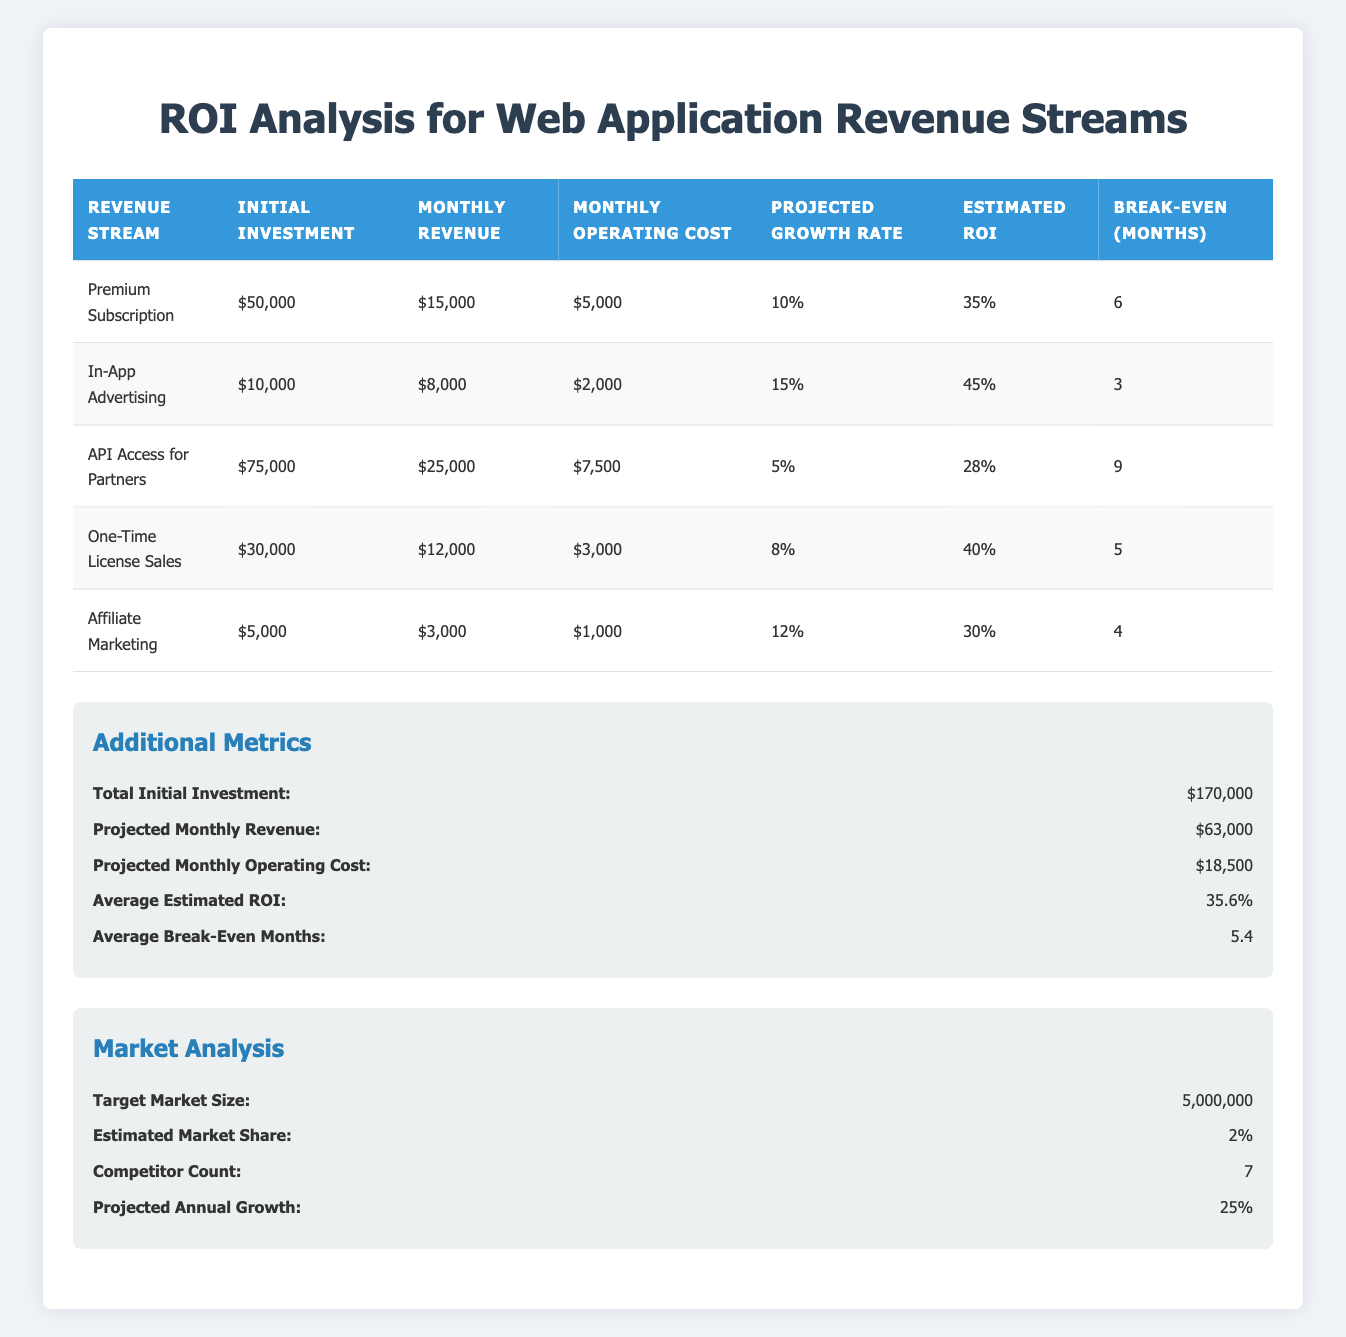What is the estimated ROI for the Premium Subscription revenue stream? The table lists the estimated ROI specifically under the Premium Subscription row, showing it as 35%.
Answer: 35% What is the initial investment required for the API Access for Partners? Looking at the API Access for Partners row, the initial investment is explicitly stated as 75,000.
Answer: 75,000 How many months does it take to break even on the One-Time License Sales? The break-even period for the One-Time License Sales is indicated in the respective row, which is 5 months.
Answer: 5 Is the total initial investment across all revenue streams greater than 150,000? The total initial investment listed is 170,000, which is greater than 150,000, making the statement true.
Answer: Yes What is the average projected monthly revenue across all revenue streams? To find the average, sum the monthly revenues: 15,000 + 8,000 + 25,000 + 12,000 + 3,000 = 63,000. Then divide by 5 (number of revenue streams): 63,000 / 5 = 12,600.
Answer: 12,600 Which revenue stream has the highest break-even months and what is that number? By comparing the break-even months across all rows, API Access for Partners has the highest value at 9 months.
Answer: 9 If we add the monthly operating costs of all streams, what total do we reach? Summing the monthly operating costs: 5,000 + 2,000 + 7,500 + 3,000 + 1,000 equals 18,500, matching the value in the additional metrics section.
Answer: 18,500 Is the estimated market share less than 3%? The estimated market share is explicitly stated as 2%, which is indeed less than 3%, making this statement true.
Answer: Yes What is the difference between the estimated ROI of In-App Advertising and Affiliate Marketing? In-App Advertising has an estimated ROI of 45% and Affiliate Marketing has 30%. Calculating the difference: 45% - 30% = 15%.
Answer: 15% 